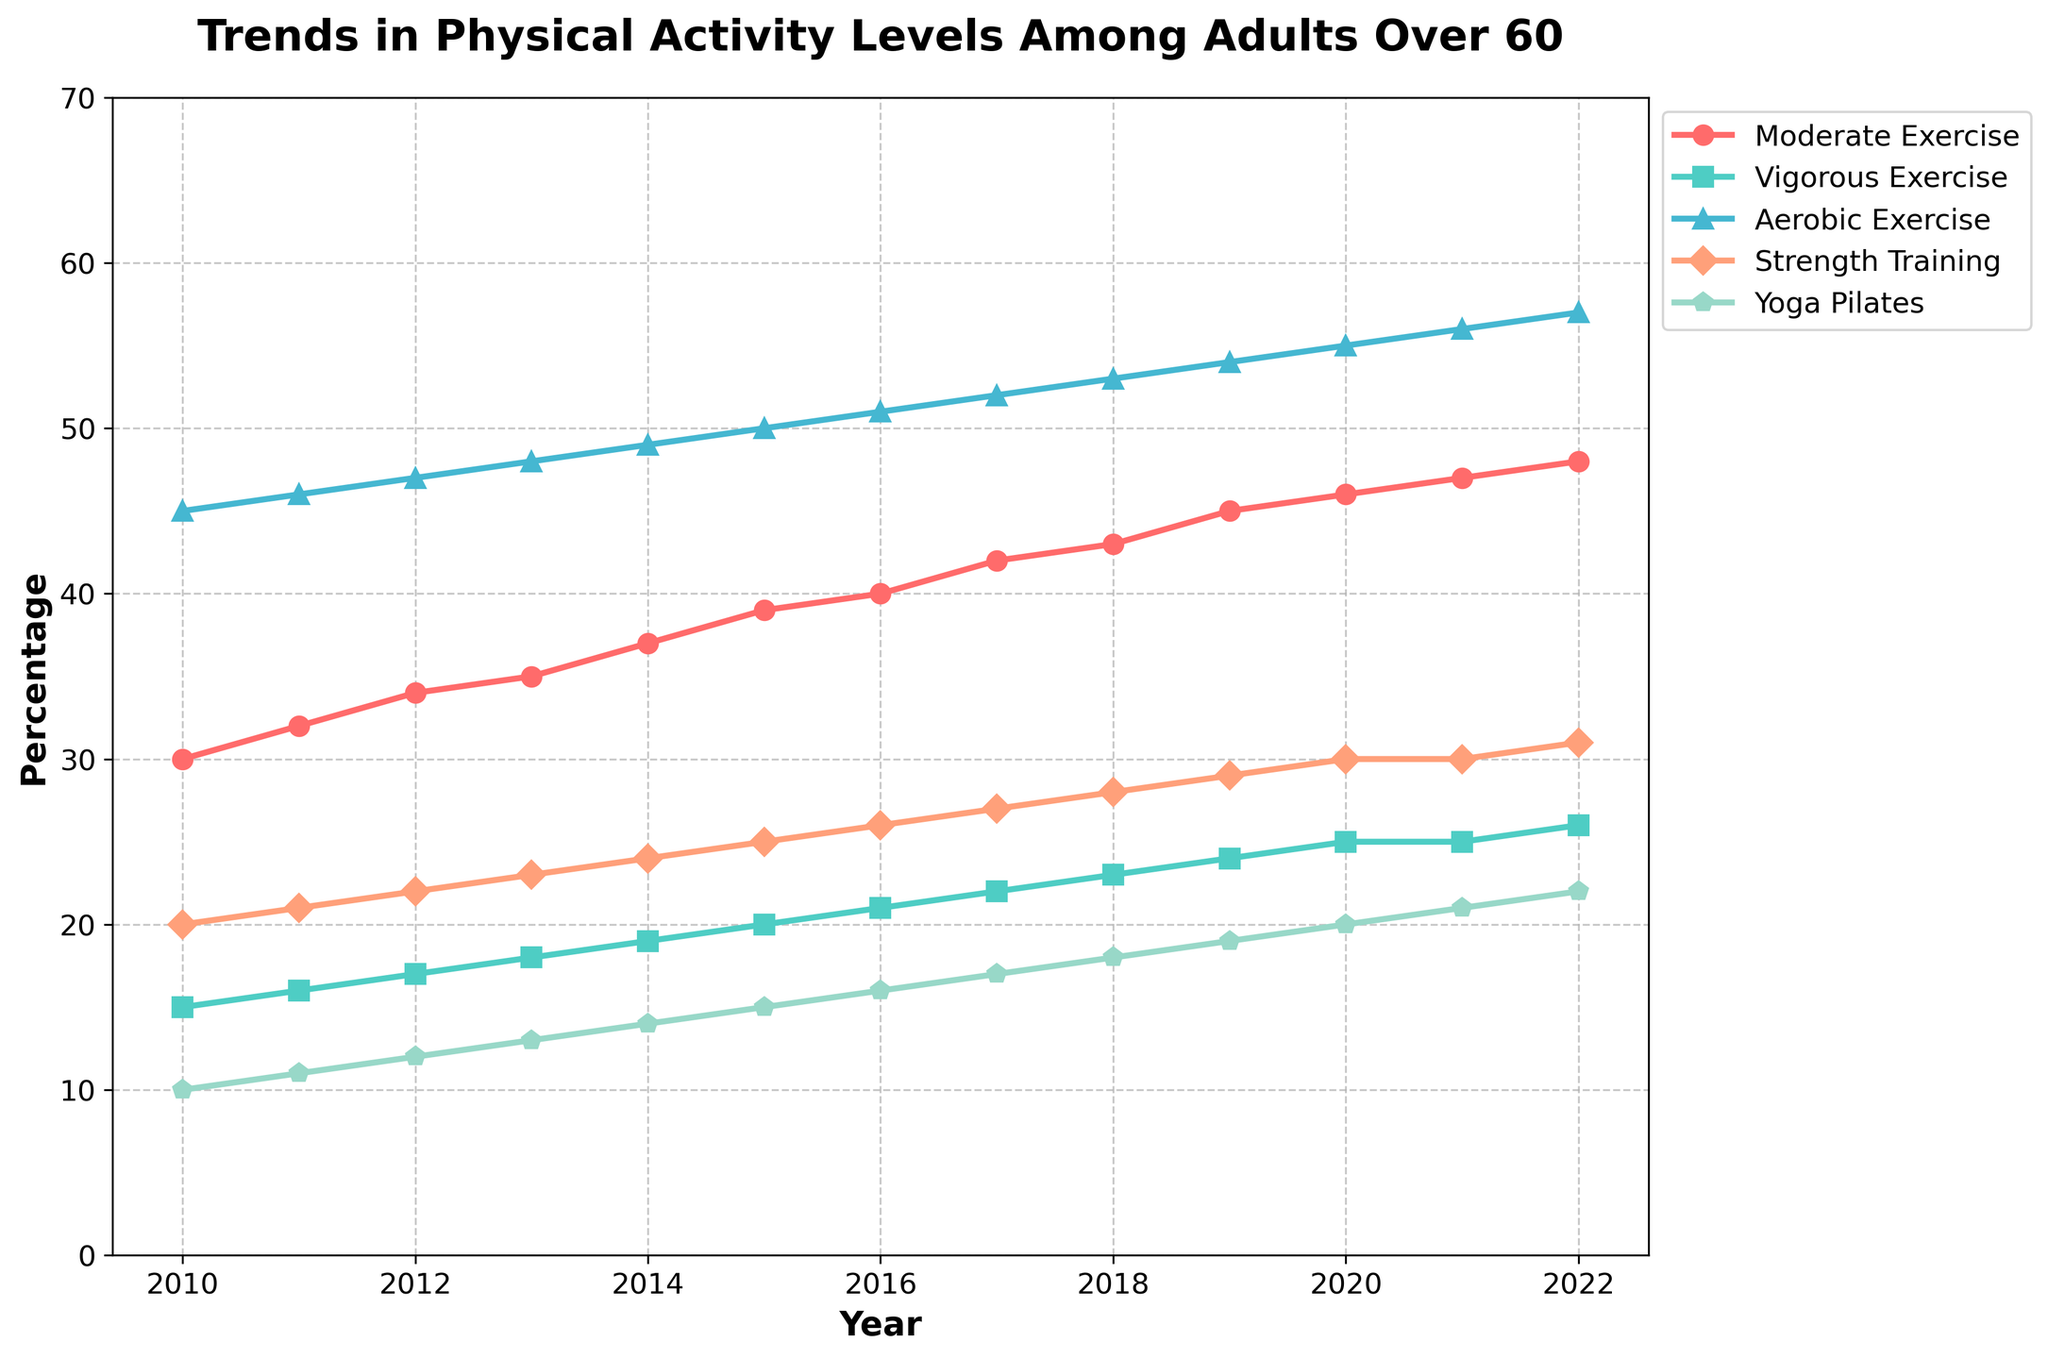How many exercise types are tracked in the figure? The figure has five distinct lines, each representing a different type of exercise. These types are named: Moderate Exercise, Vigorous Exercise, Aerobic Exercise, Strength Training, and Yoga/Pilates.
Answer: 5 What is the title of the figure? The title of the figure is written at the top and reads "Trends in Physical Activity Levels Among Adults Over 60".
Answer: Trends in Physical Activity Levels Among Adults Over 60 Which exercise type had the highest percentage in 2022? By examining the percentage values at the 2022 endpoint on the figure, Aerobic Exercise has the highest percentage.
Answer: Aerobic Exercise In which year did percentages for Moderate Exercise and Vigorous Exercise first differ by 20% or more? To find the year, we look at the difference between the percentages for Moderate and Vigorous Exercises each year, and the first year where the difference is 20% or more is 2017 (42% - 22% = 20%).
Answer: 2017 What percentage of adults participated in Strength Training in 2015? Locate the data line for Strength Training and check its value for the year 2015, which is 25%.
Answer: 25% How did the percentage of Yoga/Pilates change from 2010 to 2022? From the figure, the percentage for Yoga/Pilates in 2010 was 10%, and in 2022 it was 22%. The change is calculated as 22% - 10% = 12%.
Answer: 12% What is the overall trend for Vigorous Exercise from 2010 to 2022? By looking at the trend line for Vigorous Exercise, it consistently increases each year from 15% in 2010 to 26% in 2022.
Answer: Increasing In which year did Aerobic Exercise first exceed 50%? By examining the line for Aerobic Exercise, it first exceeds 50% in the year 2016.
Answer: 2016 What is the percentage difference between Aerobic Exercise and Strength Training in 2020? Check the figure for percentages in 2020: Aerobic Exercise is 55%, and Strength Training is 30%. The difference is 55% - 30% = 25%.
Answer: 25% Which exercise type showed the smallest increase in percentage from 2010 to 2022? By calculating the overall increase for each exercise type, Yoga/Pilates increased from 10% to 22%, which is a 12% increase, the smallest among all the exercise types.
Answer: Yoga/Pilates 